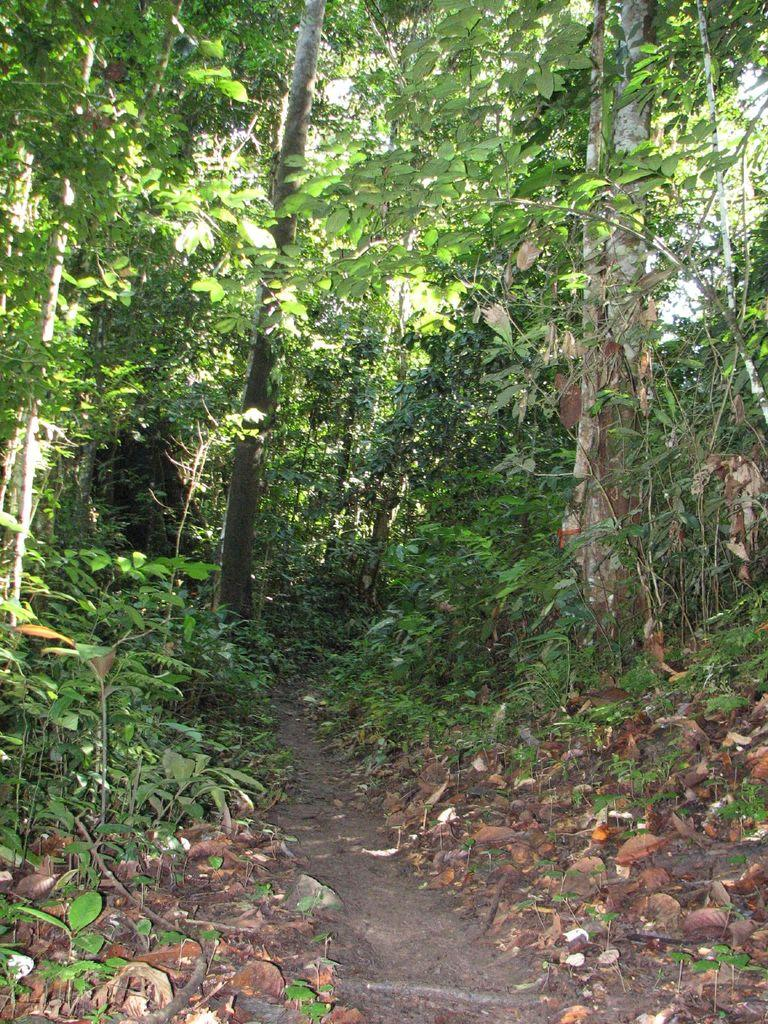What type of vegetation is present in the image? There are trees with branches and leaves in the image. What other natural elements can be seen in the image? There are rocks in the image. Can you describe any man-made structures or features in the image? There appears to be a pathway in the image. What type of music can be heard playing in the background of the image? There is no music present in the image, as it is a still photograph. 